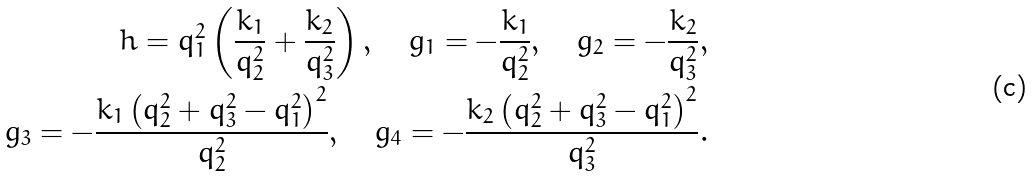Convert formula to latex. <formula><loc_0><loc_0><loc_500><loc_500>h = q _ { 1 } ^ { 2 } \left ( \frac { k _ { 1 } } { q _ { 2 } ^ { 2 } } + \frac { k _ { 2 } } { q _ { 3 } ^ { 2 } } \right ) , \quad g _ { 1 } = - \frac { k _ { 1 } } { q _ { 2 } ^ { 2 } } , \quad g _ { 2 } = - \frac { k _ { 2 } } { q _ { 3 } ^ { 2 } } , \\ g _ { 3 } = - \frac { k _ { 1 } \left ( q _ { 2 } ^ { 2 } + q _ { 3 } ^ { 2 } - q _ { 1 } ^ { 2 } \right ) ^ { 2 } } { q _ { 2 } ^ { 2 } } , \quad g _ { 4 } = - \frac { k _ { 2 } \left ( q _ { 2 } ^ { 2 } + q _ { 3 } ^ { 2 } - q _ { 1 } ^ { 2 } \right ) ^ { 2 } } { q _ { 3 } ^ { 2 } } .</formula> 